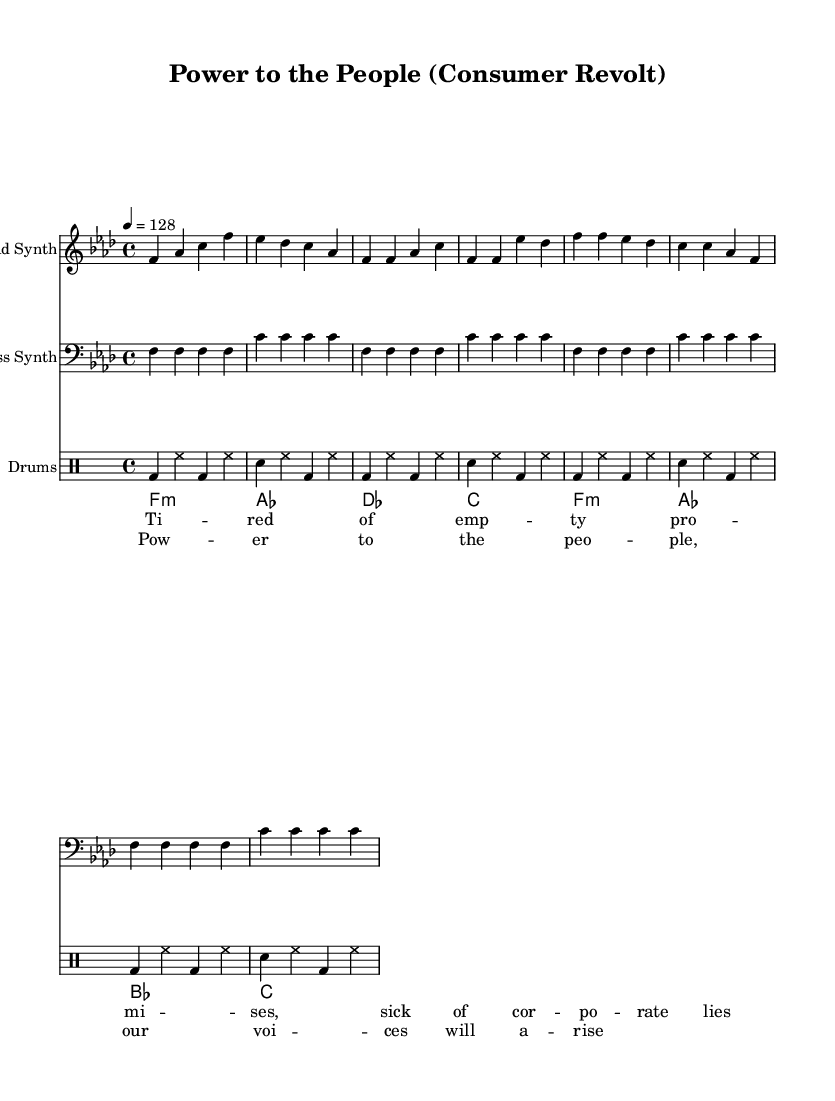What is the key signature of this music? The key signature shows three flats, indicating the music is in F minor. This can be determined by looking at the key signature listed at the beginning of the staff.
Answer: F minor What is the time signature? The time signature displayed at the beginning of the score is 4/4, which indicates four beats per measure. This can be verified by checking the notations at the beginning of the music.
Answer: 4/4 What is the tempo marking for this piece? The tempo is indicated as 128 beats per minute, showing the desired speed for the performance. This is found at the start of the score where the tempo marking is provided.
Answer: 128 How many measures are in the verse section? The verse section is made up of four measures, as indicated by the structure of the music using the repeated notation that contains four separate measures for the verse lyrics.
Answer: 4 What kind of rhythmic pattern is used in the drum section? The drum section features a pattern consisting of bass drum, hi-hat, and snare drum, repeated throughout, which is a common rhythmic approach in house music. This is identified by looking at the drummode section of the score.
Answer: Bass-HiHat-Snare What are the main lyrical themes in the chorus? The chorus conveys themes of empowerment and collective voice, focusing on social activism, as seen in the words selected for the chorus section. This requires reading and interpreting the lyrics.
Answer: Empowerment What is the instrument used for the lead part? The lead part is performed on synthesizer, which is a common instrument choice in house music for creating melodic lines. This can be determined from the staff label indicating "Lead Synth."
Answer: Lead Synth 